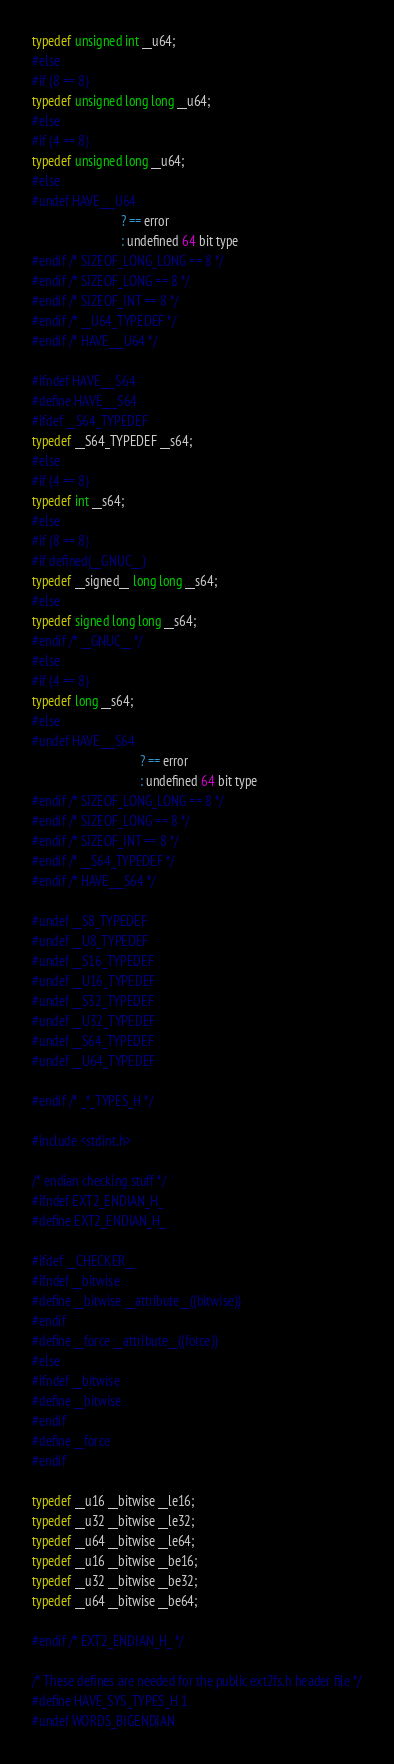Convert code to text. <code><loc_0><loc_0><loc_500><loc_500><_C_>typedef unsigned int __u64;
#else
#if (8 == 8)
typedef unsigned long long __u64;
#else
#if (4 == 8)
typedef unsigned long __u64;
#else
#undef HAVE___U64
                            ? == error
                            : undefined 64 bit type
#endif /* SIZEOF_LONG_LONG == 8 */
#endif /* SIZEOF_LONG == 8 */
#endif /* SIZEOF_INT == 8 */
#endif /* __U64_TYPEDEF */
#endif /* HAVE___U64 */

#ifndef HAVE___S64
#define HAVE___S64
#ifdef __S64_TYPEDEF
typedef __S64_TYPEDEF __s64;
#else
#if (4 == 8)
typedef int __s64;
#else
#if (8 == 8)
#if defined(__GNUC__)
typedef __signed__ long long __s64;
#else
typedef signed long long __s64;
#endif /* __GNUC__ */
#else
#if (4 == 8)
typedef long __s64;
#else
#undef HAVE___S64
                                  ? == error
                                  : undefined 64 bit type
#endif /* SIZEOF_LONG_LONG == 8 */
#endif /* SIZEOF_LONG == 8 */
#endif /* SIZEOF_INT == 8 */
#endif /* __S64_TYPEDEF */
#endif /* HAVE___S64 */

#undef __S8_TYPEDEF
#undef __U8_TYPEDEF
#undef __S16_TYPEDEF
#undef __U16_TYPEDEF
#undef __S32_TYPEDEF
#undef __U32_TYPEDEF
#undef __S64_TYPEDEF
#undef __U64_TYPEDEF

#endif /* _*_TYPES_H */

#include <stdint.h>

/* endian checking stuff */
#ifndef EXT2_ENDIAN_H_
#define EXT2_ENDIAN_H_

#ifdef __CHECKER__
#ifndef __bitwise
#define __bitwise __attribute__((bitwise))
#endif
#define __force __attribute__((force))
#else
#ifndef __bitwise
#define __bitwise
#endif
#define __force
#endif

typedef __u16 __bitwise __le16;
typedef __u32 __bitwise __le32;
typedef __u64 __bitwise __le64;
typedef __u16 __bitwise __be16;
typedef __u32 __bitwise __be32;
typedef __u64 __bitwise __be64;

#endif /* EXT2_ENDIAN_H_ */

/* These defines are needed for the public ext2fs.h header file */
#define HAVE_SYS_TYPES_H 1
#undef WORDS_BIGENDIAN
</code> 